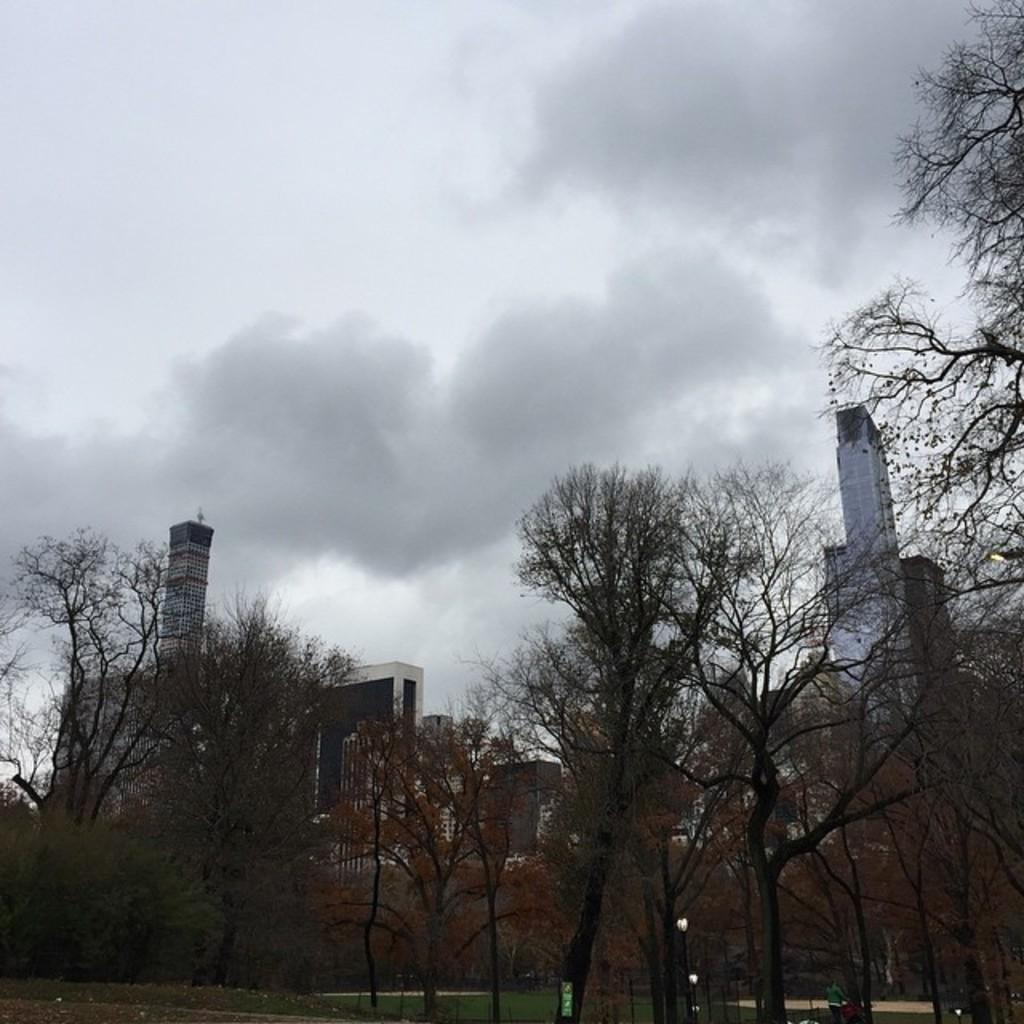What type of structures can be seen in the image? There are buildings in the image. What other natural elements are present in the image? There are trees in the image. What part of the natural environment is visible in the image? The sky is visible in the image. What color is the tongue of the person in the image? There is no person present in the image, and therefore no tongue to observe. 